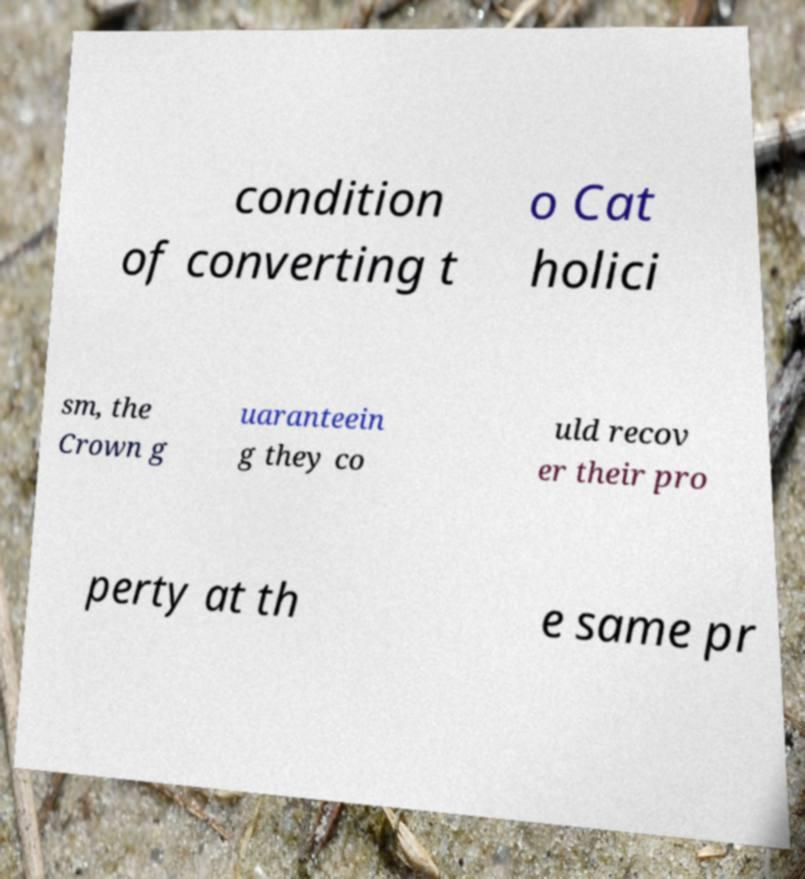Could you assist in decoding the text presented in this image and type it out clearly? condition of converting t o Cat holici sm, the Crown g uaranteein g they co uld recov er their pro perty at th e same pr 